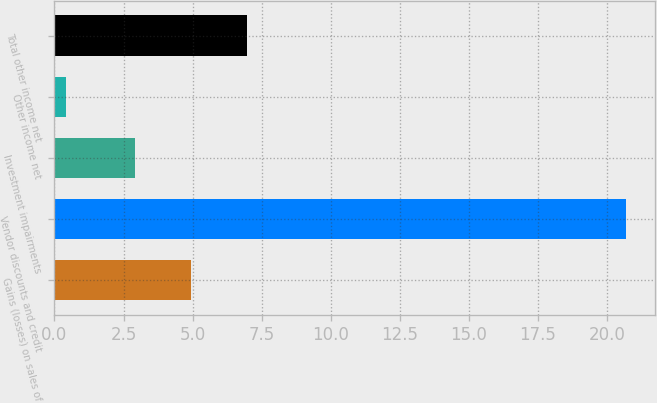<chart> <loc_0><loc_0><loc_500><loc_500><bar_chart><fcel>Gains (losses) on sales of<fcel>Vendor discounts and credit<fcel>Investment impairments<fcel>Other income net<fcel>Total other income net<nl><fcel>4.93<fcel>20.7<fcel>2.9<fcel>0.4<fcel>6.96<nl></chart> 